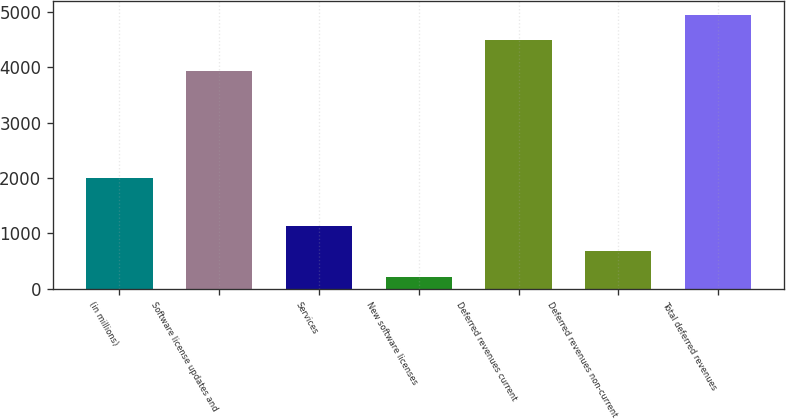Convert chart to OTSL. <chart><loc_0><loc_0><loc_500><loc_500><bar_chart><fcel>(in millions)<fcel>Software license updates and<fcel>Services<fcel>New software licenses<fcel>Deferred revenues current<fcel>Deferred revenues non-current<fcel>Total deferred revenues<nl><fcel>2008<fcel>3939<fcel>1126.8<fcel>220<fcel>4492<fcel>673.4<fcel>4945.4<nl></chart> 